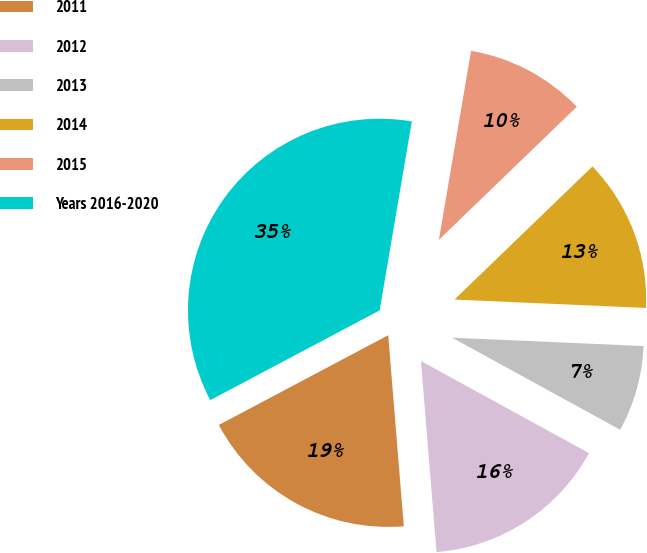Convert chart to OTSL. <chart><loc_0><loc_0><loc_500><loc_500><pie_chart><fcel>2011<fcel>2012<fcel>2013<fcel>2014<fcel>2015<fcel>Years 2016-2020<nl><fcel>18.54%<fcel>15.73%<fcel>7.28%<fcel>12.91%<fcel>10.1%<fcel>35.44%<nl></chart> 